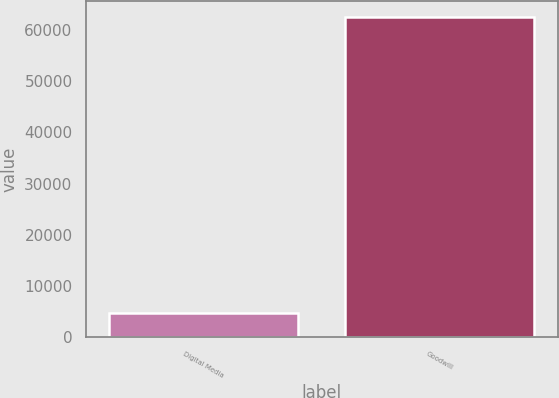Convert chart to OTSL. <chart><loc_0><loc_0><loc_500><loc_500><bar_chart><fcel>Digital Media<fcel>Goodwill<nl><fcel>4838<fcel>62529<nl></chart> 